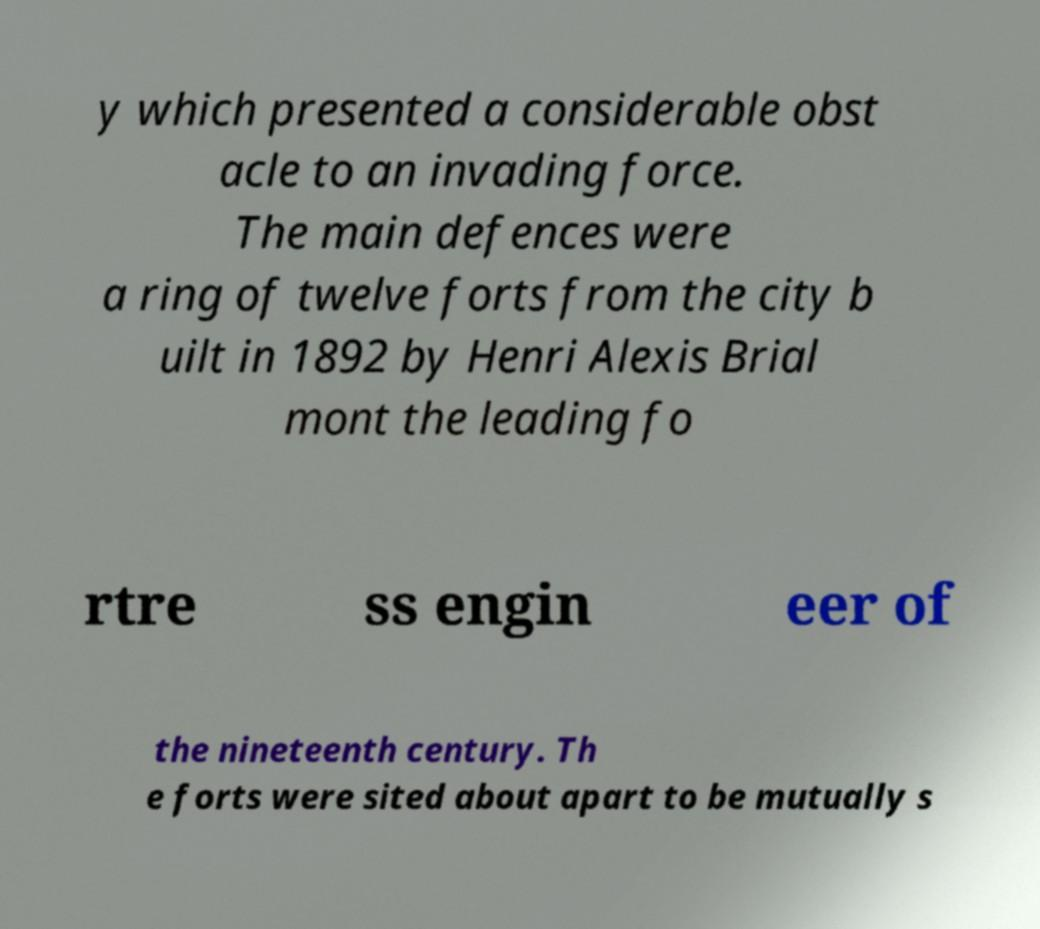For documentation purposes, I need the text within this image transcribed. Could you provide that? y which presented a considerable obst acle to an invading force. The main defences were a ring of twelve forts from the city b uilt in 1892 by Henri Alexis Brial mont the leading fo rtre ss engin eer of the nineteenth century. Th e forts were sited about apart to be mutually s 